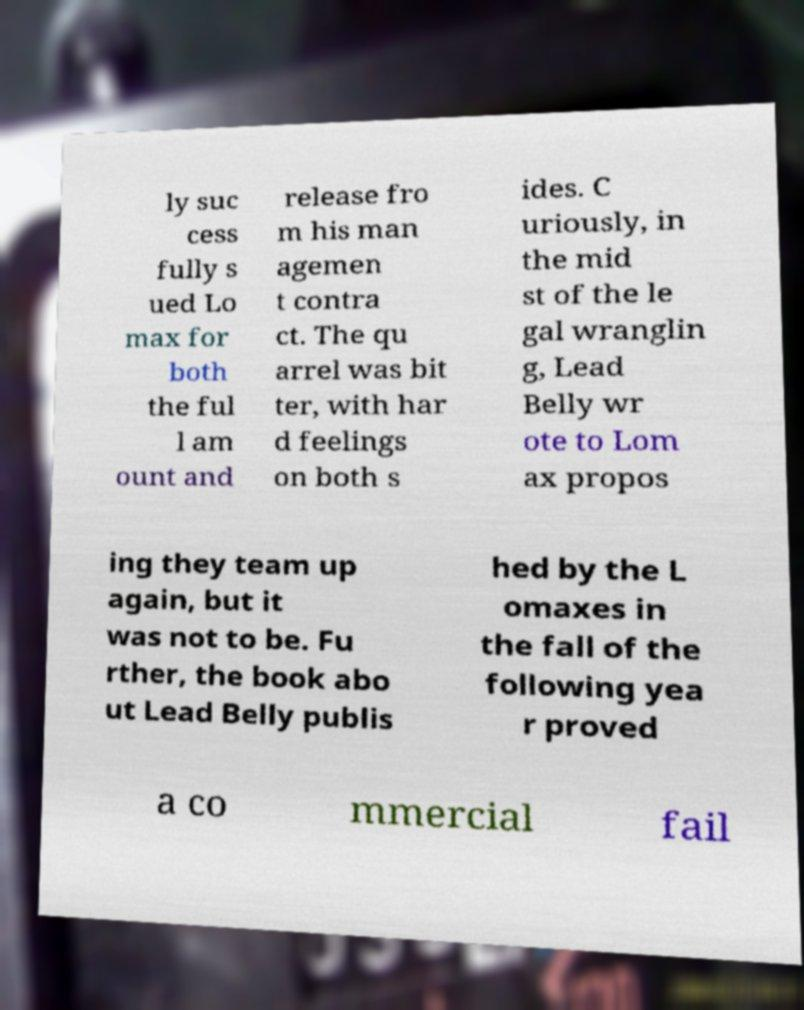Could you assist in decoding the text presented in this image and type it out clearly? ly suc cess fully s ued Lo max for both the ful l am ount and release fro m his man agemen t contra ct. The qu arrel was bit ter, with har d feelings on both s ides. C uriously, in the mid st of the le gal wranglin g, Lead Belly wr ote to Lom ax propos ing they team up again, but it was not to be. Fu rther, the book abo ut Lead Belly publis hed by the L omaxes in the fall of the following yea r proved a co mmercial fail 